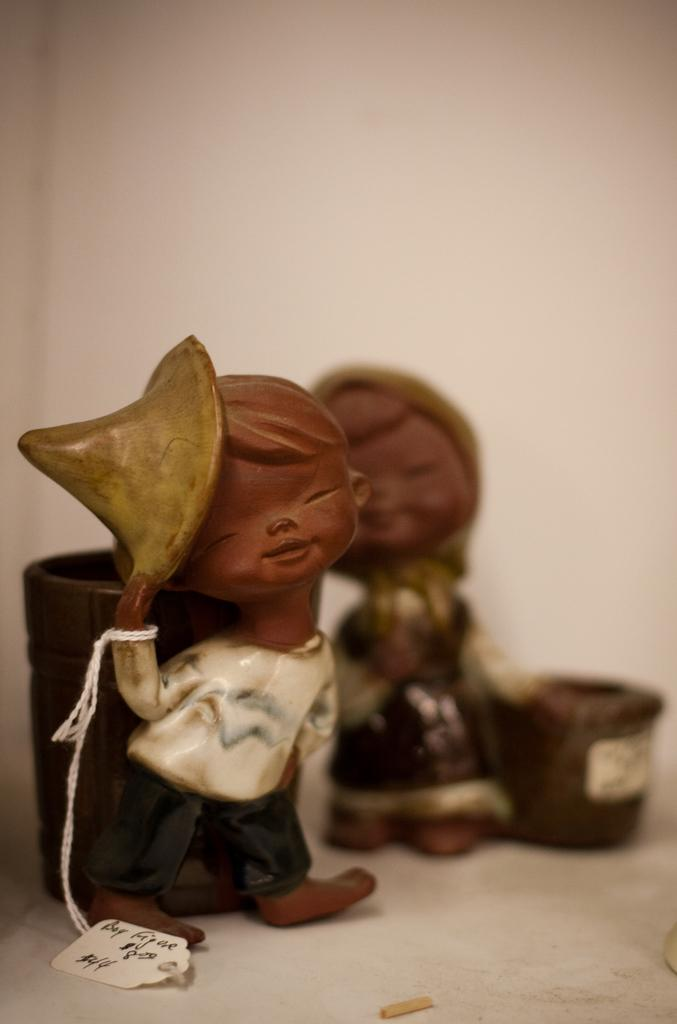What is the main subject of the image? There is a doll in the image. Can you describe the doll's position or appearance? The doll is the main subject, but there is another doll behind it, which is blurred. What type of rice can be seen growing in the garden behind the dolls? There is no garden or rice present in the image; it only features two dolls. 